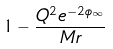<formula> <loc_0><loc_0><loc_500><loc_500>1 - { \frac { Q ^ { 2 } e ^ { - 2 \phi _ { \infty } } } { M r } }</formula> 